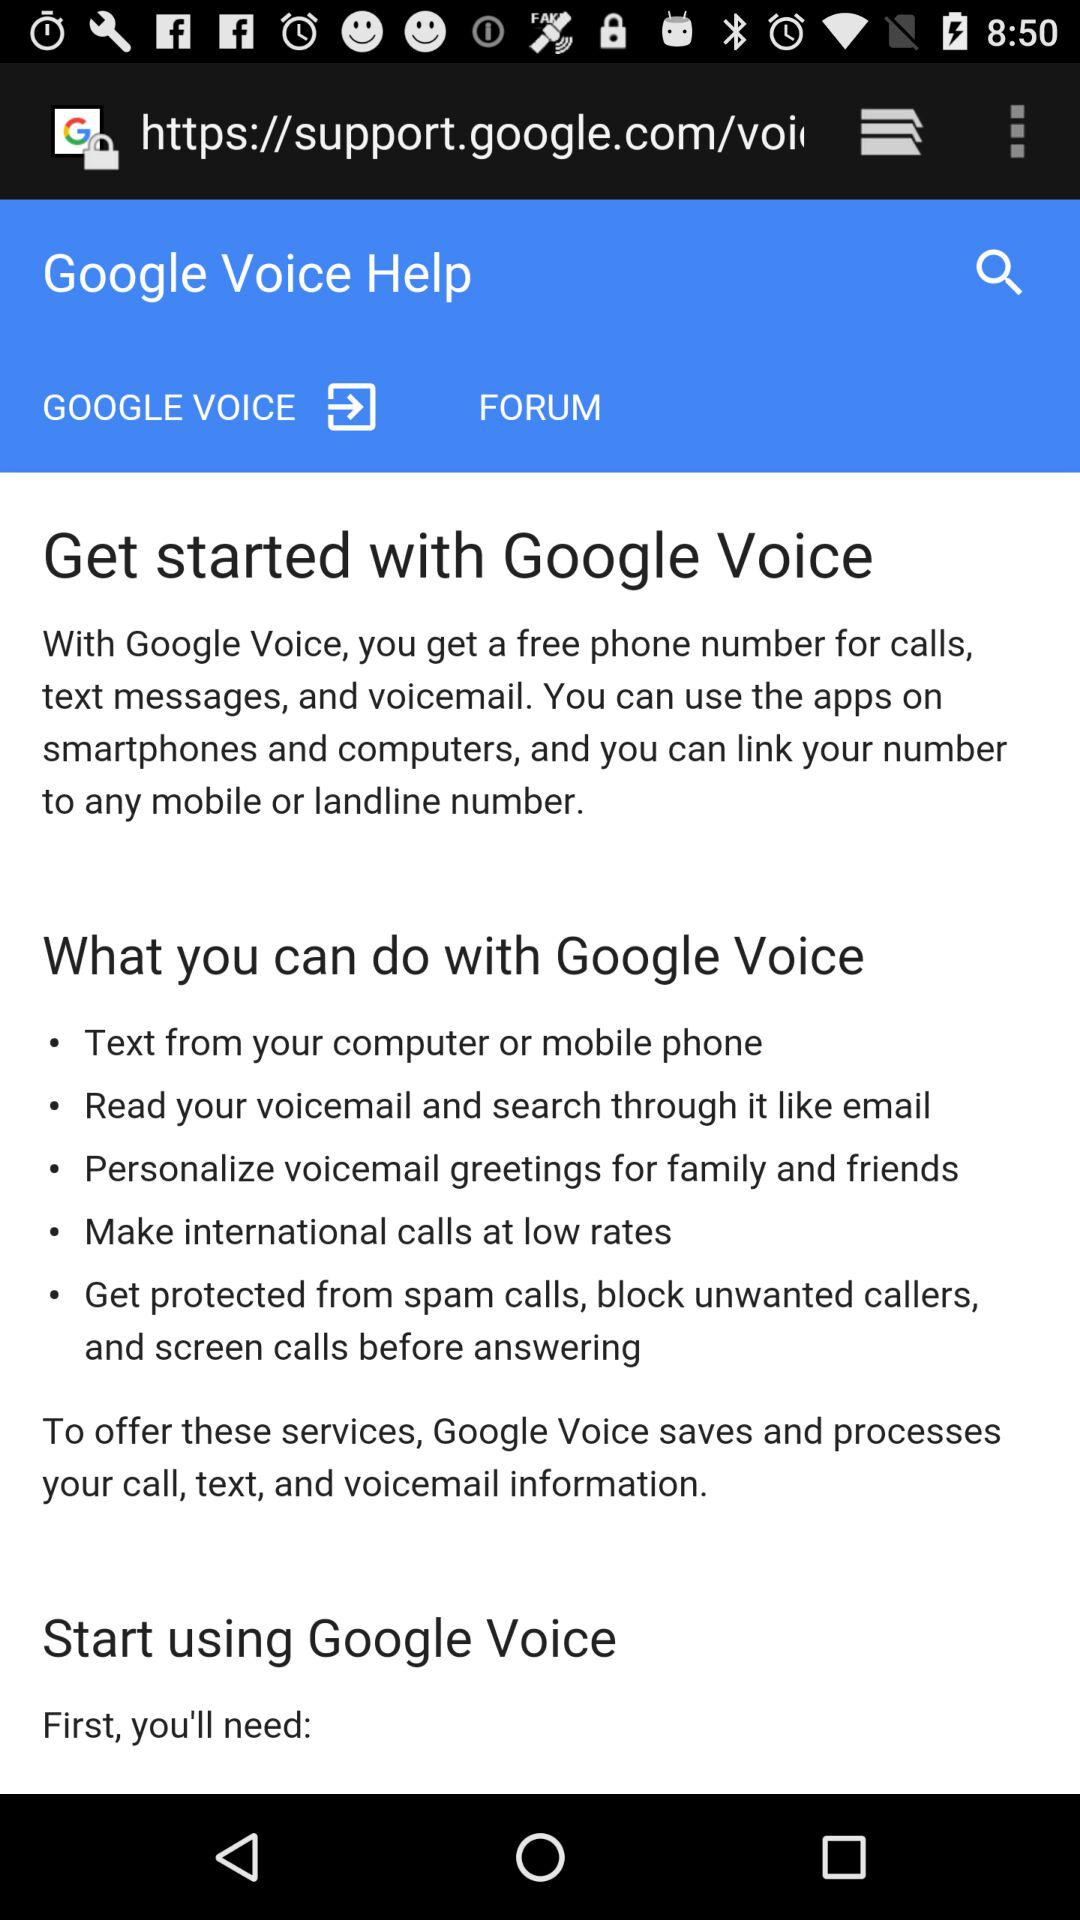What can we get with Google Voice for calls? You can get a free phone number. 